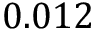Convert formula to latex. <formula><loc_0><loc_0><loc_500><loc_500>0 . 0 1 2</formula> 